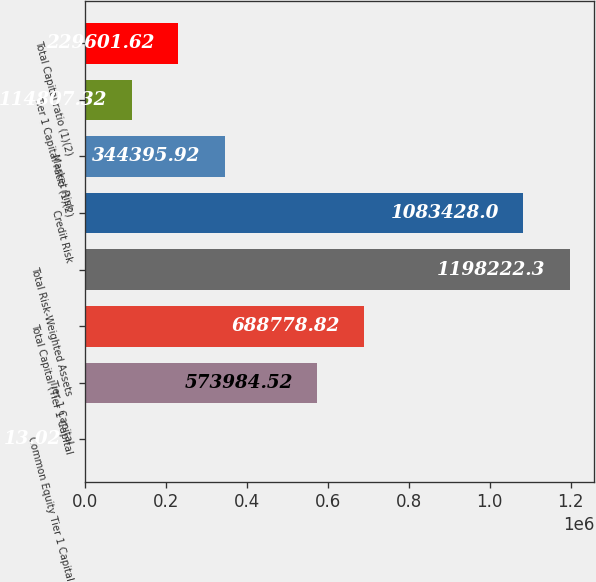Convert chart. <chart><loc_0><loc_0><loc_500><loc_500><bar_chart><fcel>Common Equity Tier 1 Capital<fcel>Tier 1 Capital<fcel>Total Capital (Tier 1 Capital<fcel>Total Risk-Weighted Assets<fcel>Credit Risk<fcel>Market Risk<fcel>Tier 1 Capital ratio (1)(2)<fcel>Total Capital ratio (1)(2)<nl><fcel>13.02<fcel>573985<fcel>688779<fcel>1.19822e+06<fcel>1.08343e+06<fcel>344396<fcel>114807<fcel>229602<nl></chart> 